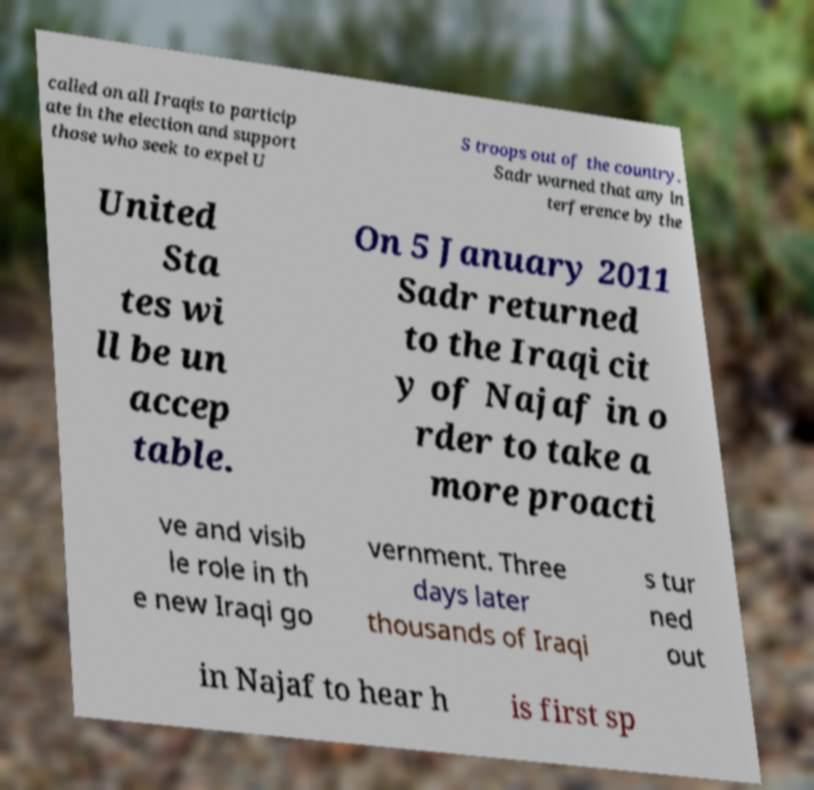Can you accurately transcribe the text from the provided image for me? called on all Iraqis to particip ate in the election and support those who seek to expel U S troops out of the country. Sadr warned that any in terference by the United Sta tes wi ll be un accep table. On 5 January 2011 Sadr returned to the Iraqi cit y of Najaf in o rder to take a more proacti ve and visib le role in th e new Iraqi go vernment. Three days later thousands of Iraqi s tur ned out in Najaf to hear h is first sp 